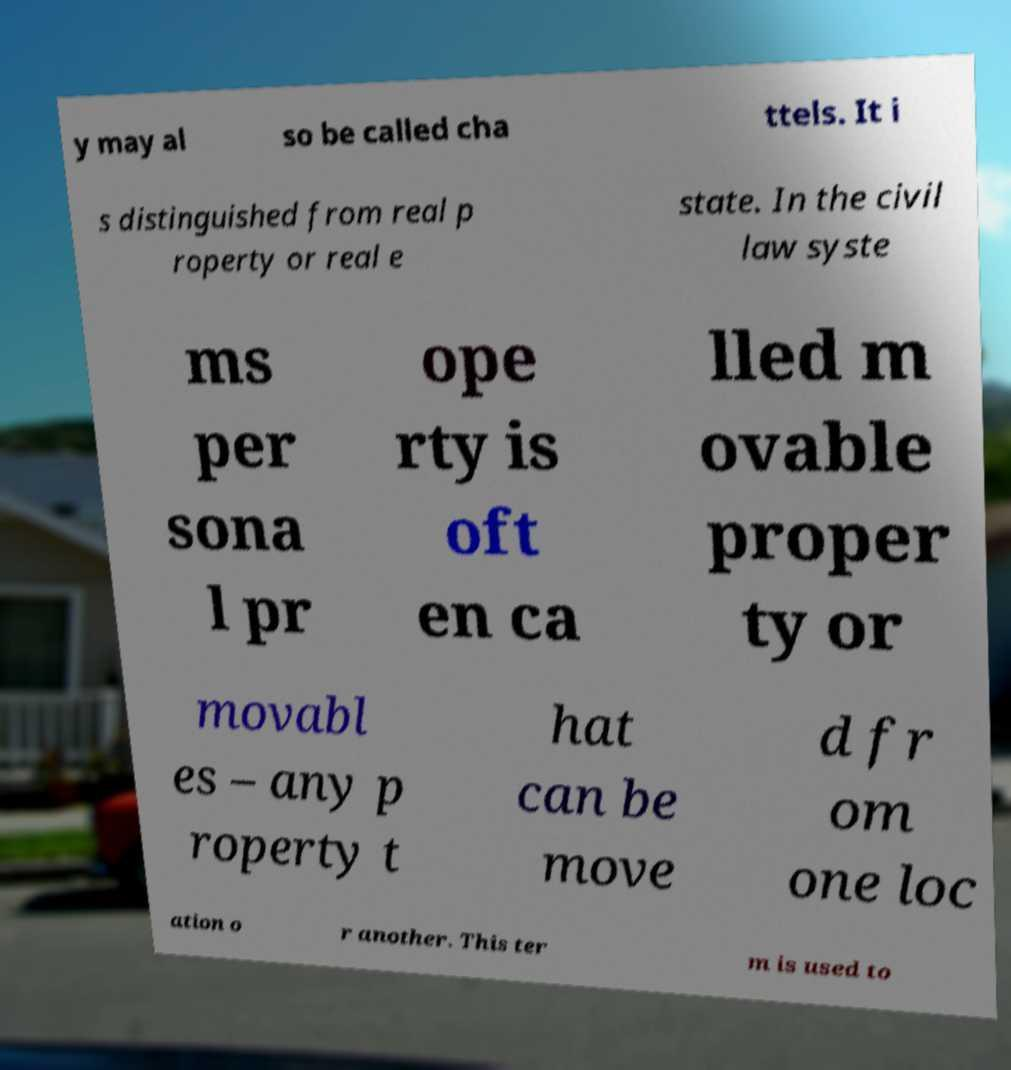Could you assist in decoding the text presented in this image and type it out clearly? y may al so be called cha ttels. It i s distinguished from real p roperty or real e state. In the civil law syste ms per sona l pr ope rty is oft en ca lled m ovable proper ty or movabl es – any p roperty t hat can be move d fr om one loc ation o r another. This ter m is used to 